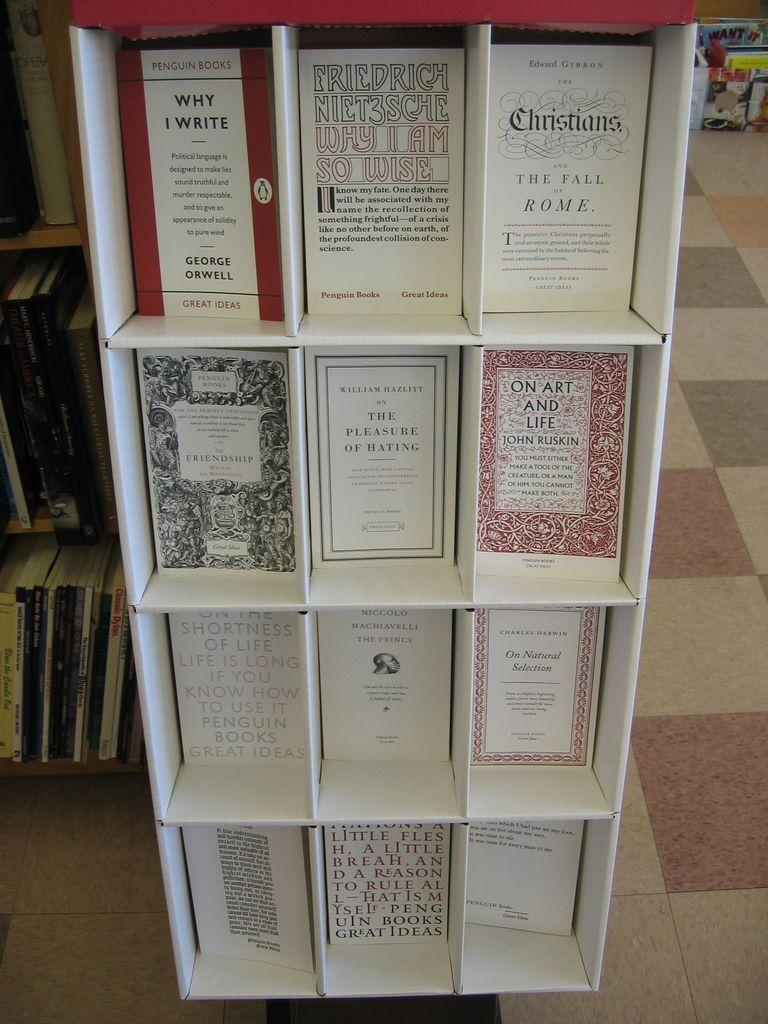<image>
Provide a brief description of the given image. A shelf of books is displayed with Why I Write, Why I am so Wise, and The Fall of Rome on top. 